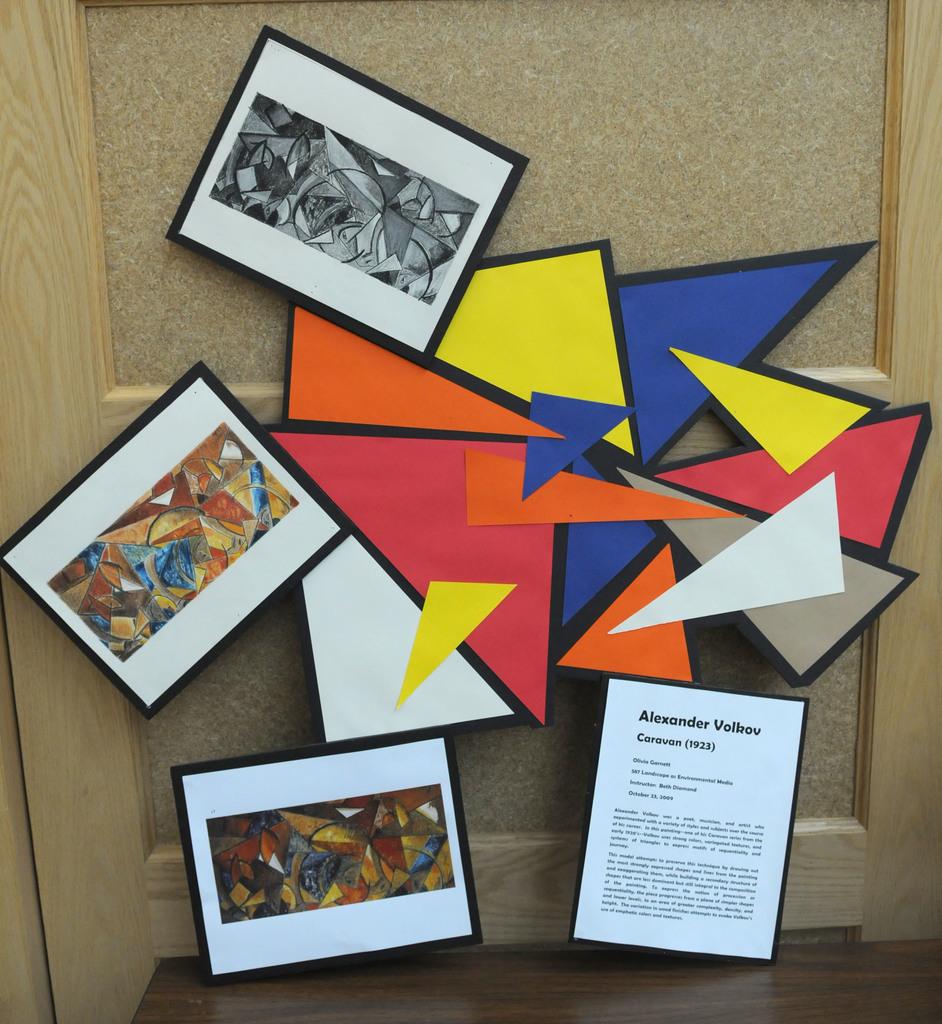Who made this art piece?
Your answer should be very brief. Alexander volkov. In what year was the piece made?
Ensure brevity in your answer.  1923. 